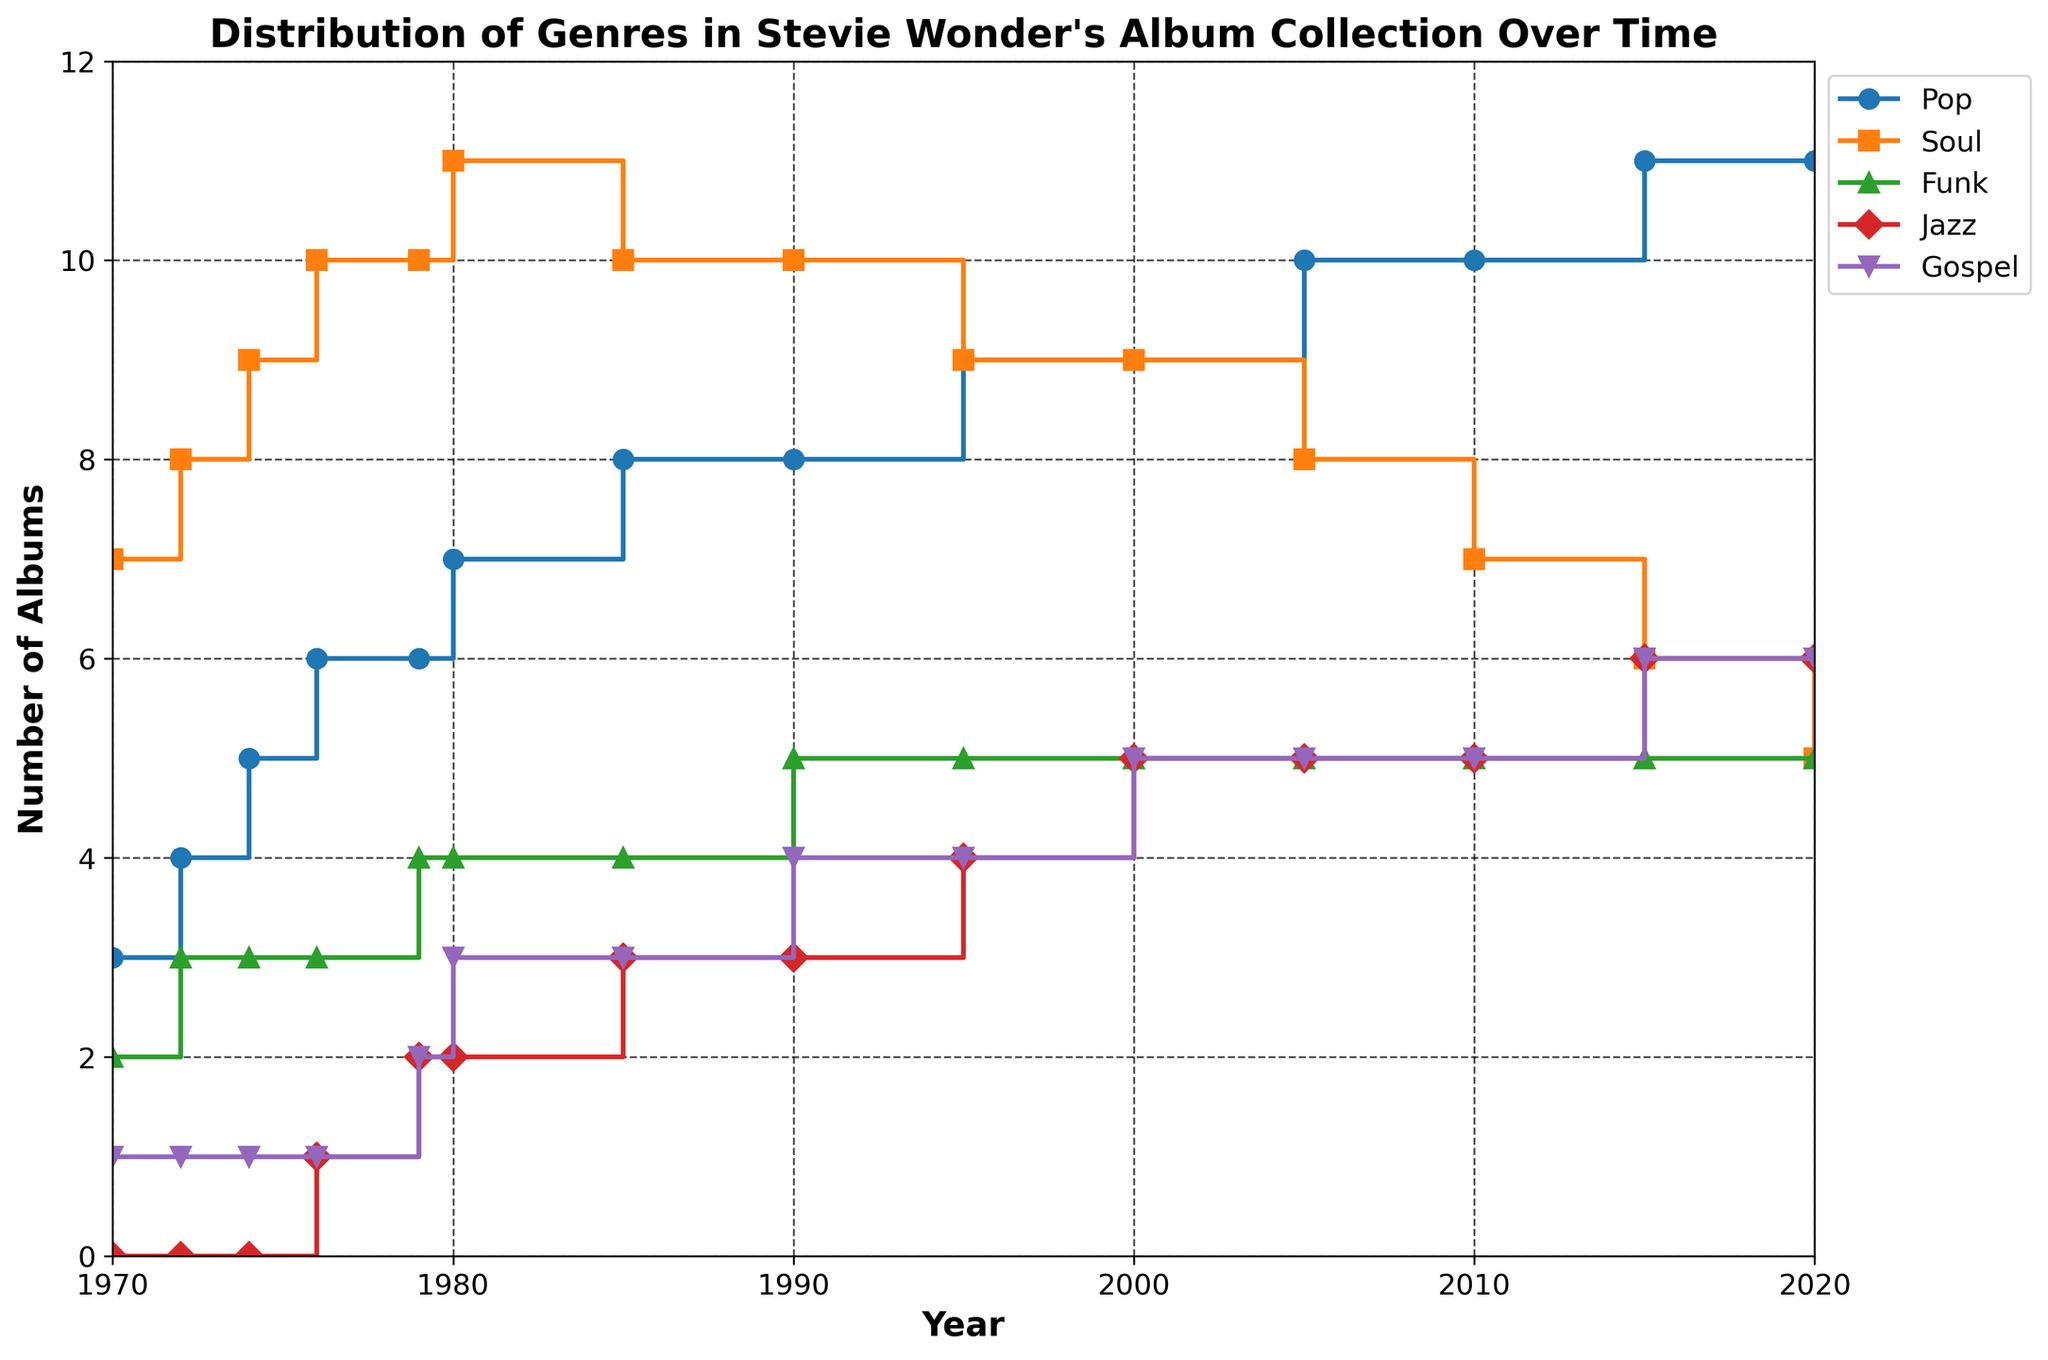What is the title of the plot? The title is located at the top of the plot and is written in bold text, indicating the main subject of the visualization.
Answer: Distribution of Genres in Stevie Wonder's Album Collection Over Time How many total albums are categorized under 'Jazz' by 2020? To determine the total number of Jazz albums by 2020, look at the step height corresponding to the year 2020 for the 'Jazz' genre.
Answer: 6 Which genre had the highest number of albums in 1976? Examine the heights of the steps for each genre in the year 1976 and identify the tallest one. 'Soul' is the highest at this point.
Answer: Soul Describe the trend of 'Pop' albums from 1970 to 2020. Look at the steps corresponding to 'Pop' and observe the overall direction and changes over time. The 'Pop' genre shows a general increase in the number of albums over the years.
Answer: Increasing How does the number of 'Gospel' albums in 1990 compare to that in 2000? Check the values of 'Gospel' albums for the years 1990 and 2000 and compare them. Both have the same number of albums.
Answer: Same What is the average number of 'Soul' albums between 1970 and 2020? Sum the number of 'Soul' albums for all the years and then divide by the total number of data points (13). (7+8+9+10+10+11+10+10+9+9+8+7+6)/13 ≈ 8.538
Answer: 8.538 Which genre showed the least variation in the number of albums from 1970 to 2020? Compare the ranges (maximum - minimum) of the number of albums for each genre over the years. 'Funk' has the least variation with values consistently around 4-5 from 1970 onwards.
Answer: Funk How many more 'Gospel' albums are there in 2020 compared to 1970? Subtract the number of 'Gospel' albums in 1970 from that in 2020. 6 - 1 = 5
Answer: 5 What is the difference in the number of 'Pop' and 'Soul' albums in the year 2010? Find the number of 'Pop' and 'Soul' albums in 2010 and subtract the value for 'Soul' from 'Pop'. 10 - 7 = 3
Answer: 3 How does the distribution of 'Funk' albums change from 1995 to 2020? Examine the step heights for 'Funk' from 1995 to 2020, noting that the values remain at 5 consistently.
Answer: Constant 